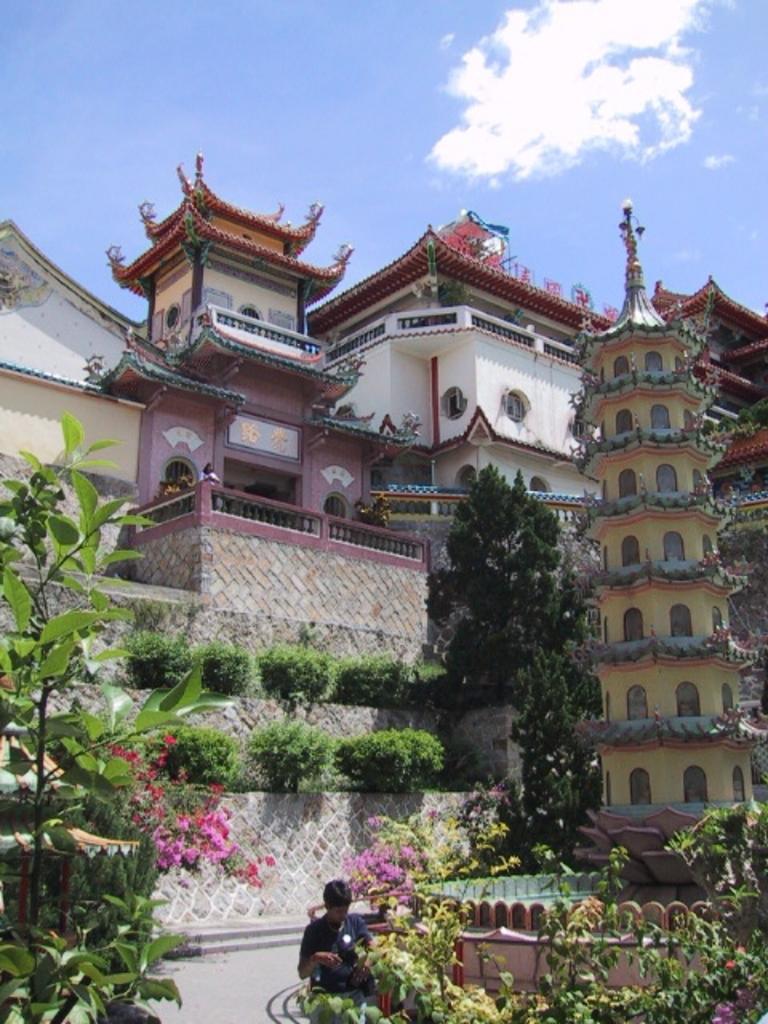Describe this image in one or two sentences. In this image there are many buildings and in front of those buildings there are few plants and trees, there is a person standing in front of one of the tree. 